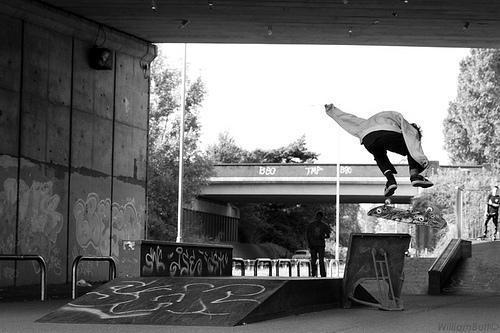How many people?
Give a very brief answer. 3. 